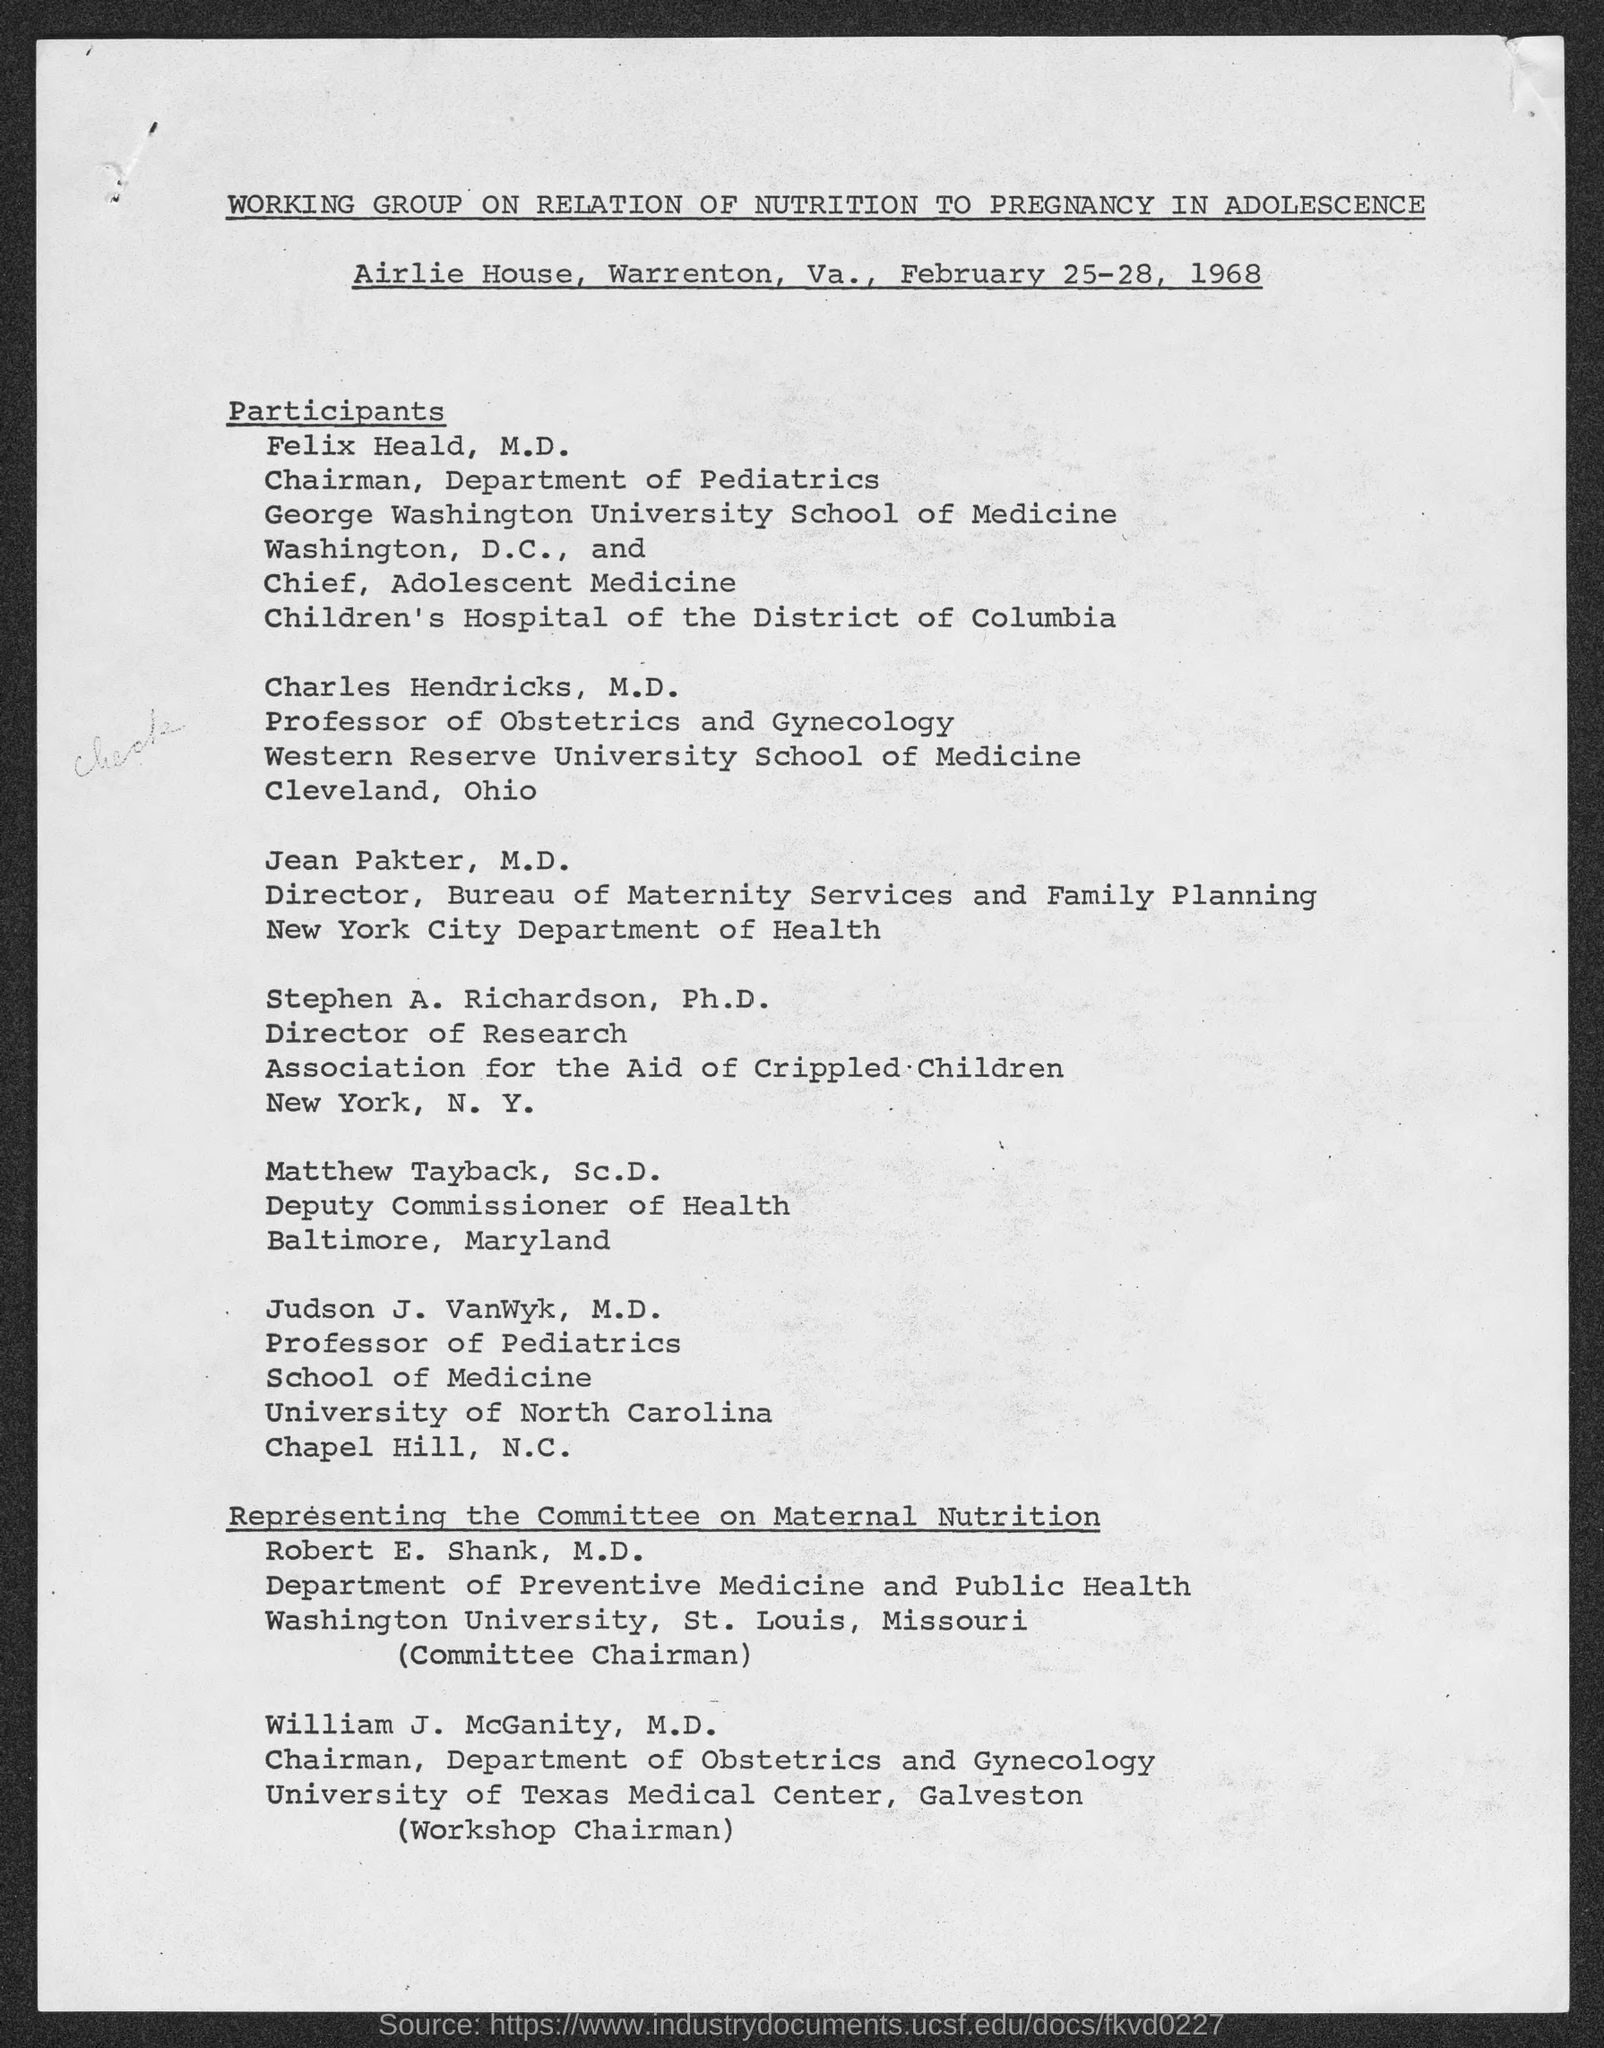Identify some key points in this picture. The Department of Pediatrics is led by Felix Heald, M.D., who serves as the chairman of the department. The director of the Bureau of Maternity Services and Family Planning is Jean Pakter, M.D. Judson J. VanWyk is the professor of pediatrics. Matthew Tayback, Sc.D., is the current deputy commissioner of Health for Baltimore, Maryland. The professor of Obstetrics and Gynecology is Charles Hendricks, M.D. 